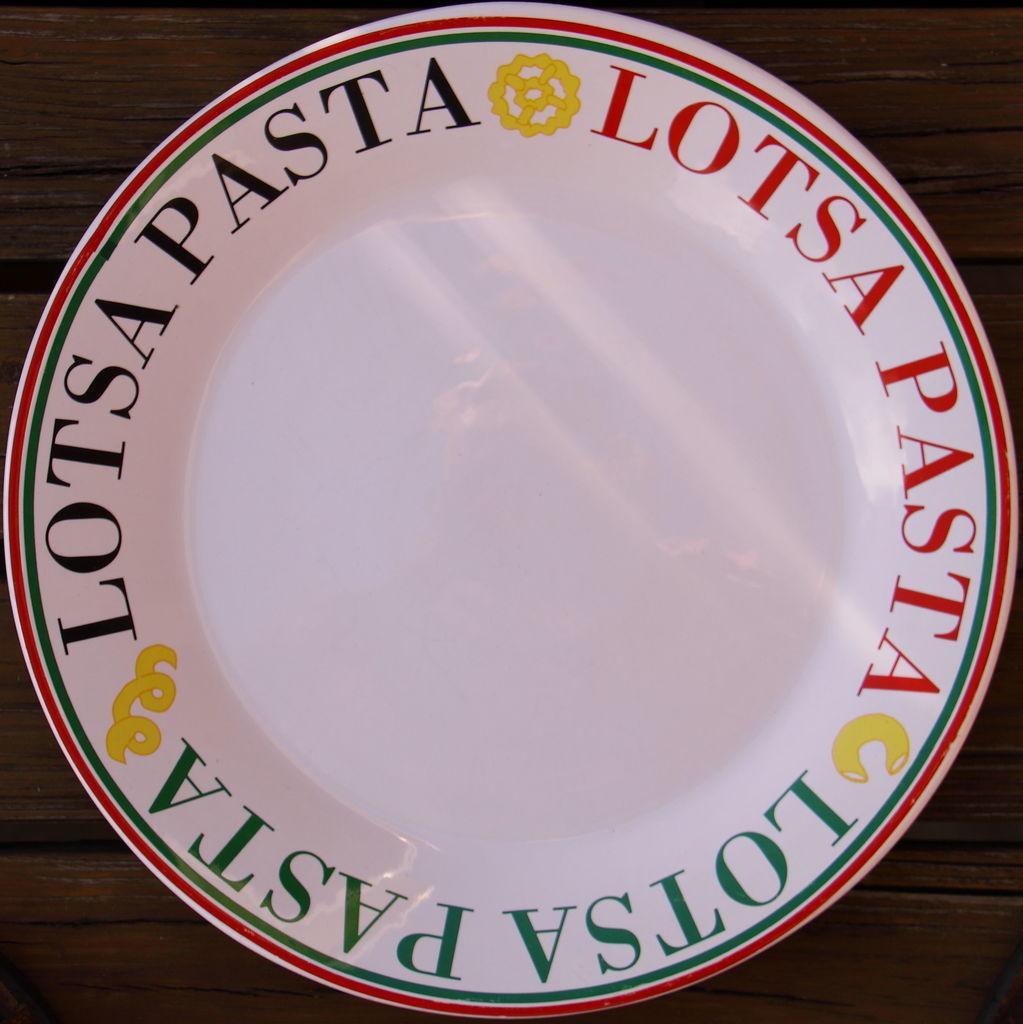Describe this image in one or two sentences. In this image we can see the white color where in the edges we can see some text which is placed on the wooden surface. 